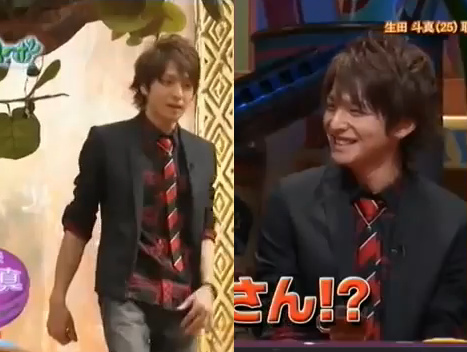Is the hair both long and black? Yes, the hair is indeed both long and black. 